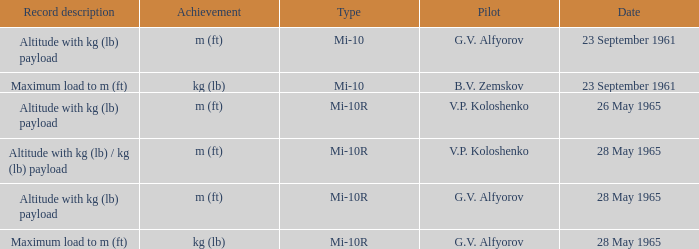Record description of altitude with kg (lb) payload, and a Pilot of g.v. alfyorov had what type? Mi-10, Mi-10R. 